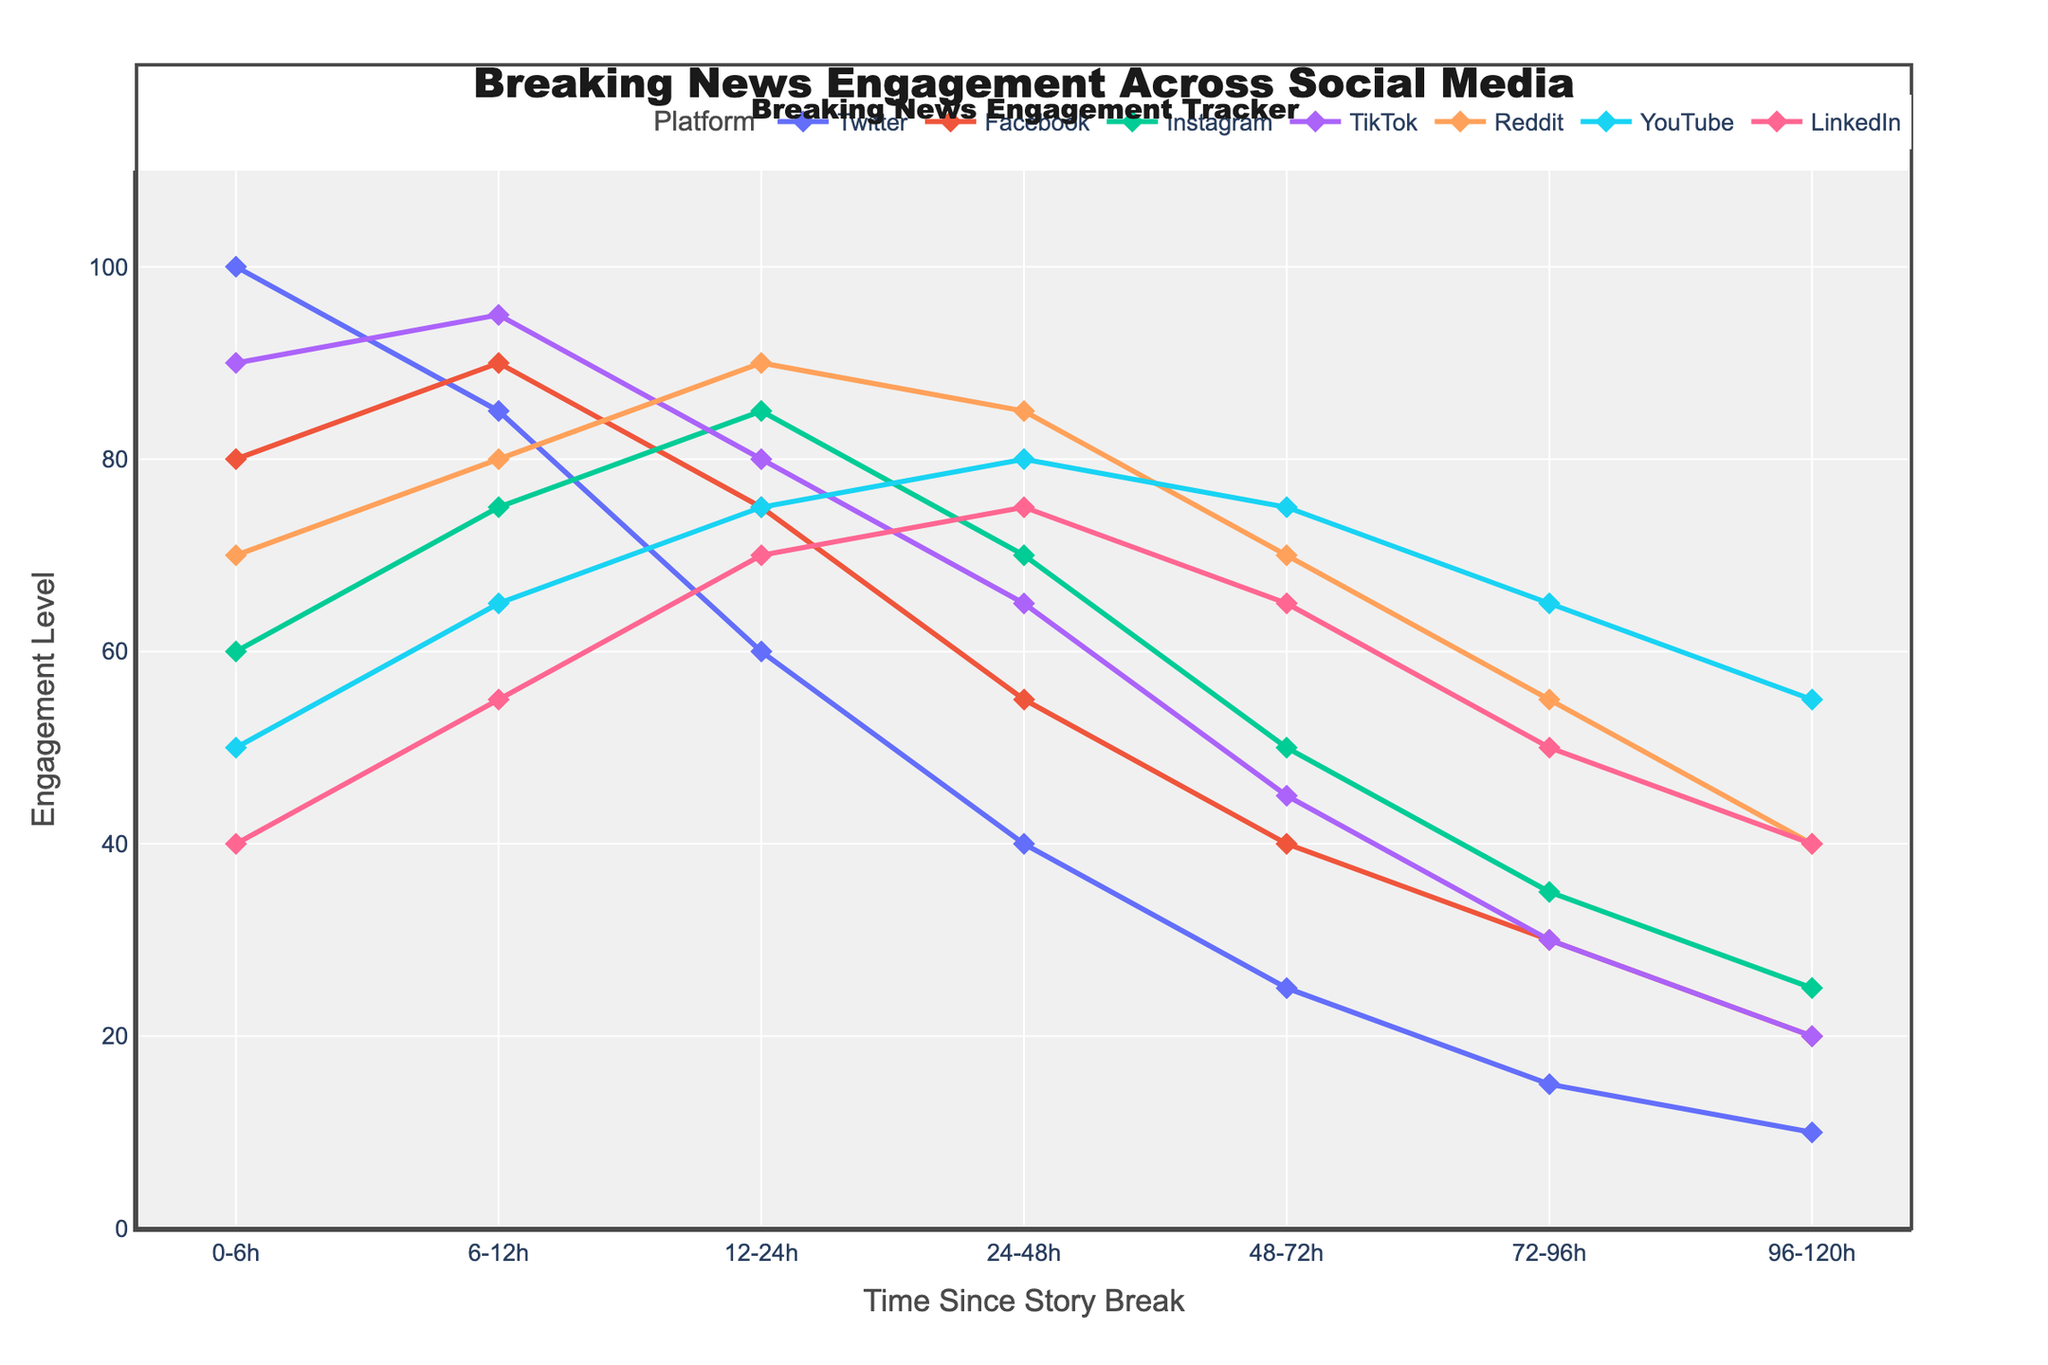Which platform has the highest engagement in the first 12 hours? Looking at the first 12-hour mark, TikTok has the highest engagement with a value of 95.
Answer: TikTok Which platform shows a consistent increase in engagement from 0-12h to 12-24h? From the figure, only Instagram shows a consistent increase in engagement, from 60 at 0-6h, 75 at 6-12h, and 85 at 12-24h.
Answer: Instagram Between Twitter and Facebook, which platform has a higher engagement at the 24-48h mark and by how much? Twitter has an engagement of 40, while Facebook has 55 at the 24-48h mark. The difference is 55 - 40 = 15.
Answer: Facebook, by 15 What is the average engagement level for LinkedIn from 0-120h? Adding the engagement levels for LinkedIn across all time periods (40 + 55 + 70 + 75 + 65 + 50 + 40) gives 395. Dividing by 7 time periods, the average is 395 / 7 ≈ 56.43.
Answer: 56.43 Which platforms have an engagement drop from 0-6h to 6-12h? Twitter drops from 100 to 85, TikTok from 90 to 95, YouTube from 50 to 65, indicating an increase, and LinkedIn from 40 to 55 showing an increase, so only Twitter.
Answer: Twitter Between the 24-48h and 48-72h marks, which platform shows the largest decrease in engagement? Comparing the values, the largest decrease is on Reddit from 85 to 70, a difference of 15.
Answer: Reddit Which platform has the highest engagement value at 96-120h? Reviewing the data, YouTube has the highest engagement at 55 in the 96-120h period.
Answer: YouTube 